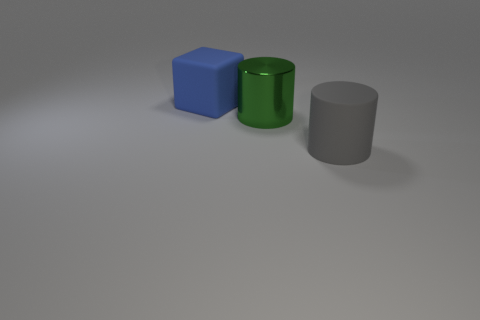Are there any other things that have the same material as the large green thing?
Keep it short and to the point. No. How many small objects are blue rubber objects or shiny cylinders?
Make the answer very short. 0. Are there any large green cylinders behind the green cylinder?
Offer a very short reply. No. Are there the same number of matte cylinders right of the big blue block and big matte blocks?
Your response must be concise. Yes. There is another shiny thing that is the same shape as the gray thing; what size is it?
Offer a very short reply. Large. There is a large blue thing; does it have the same shape as the big green metallic thing that is left of the large gray rubber cylinder?
Offer a terse response. No. There is a rubber block behind the cylinder that is behind the large rubber cylinder; how big is it?
Provide a short and direct response. Large. Are there the same number of rubber cubes that are in front of the green shiny object and metallic cylinders in front of the large gray matte thing?
Keep it short and to the point. Yes. What is the color of the other large rubber object that is the same shape as the green thing?
Provide a short and direct response. Gray. How many large metallic objects are the same color as the rubber cylinder?
Offer a very short reply. 0. 